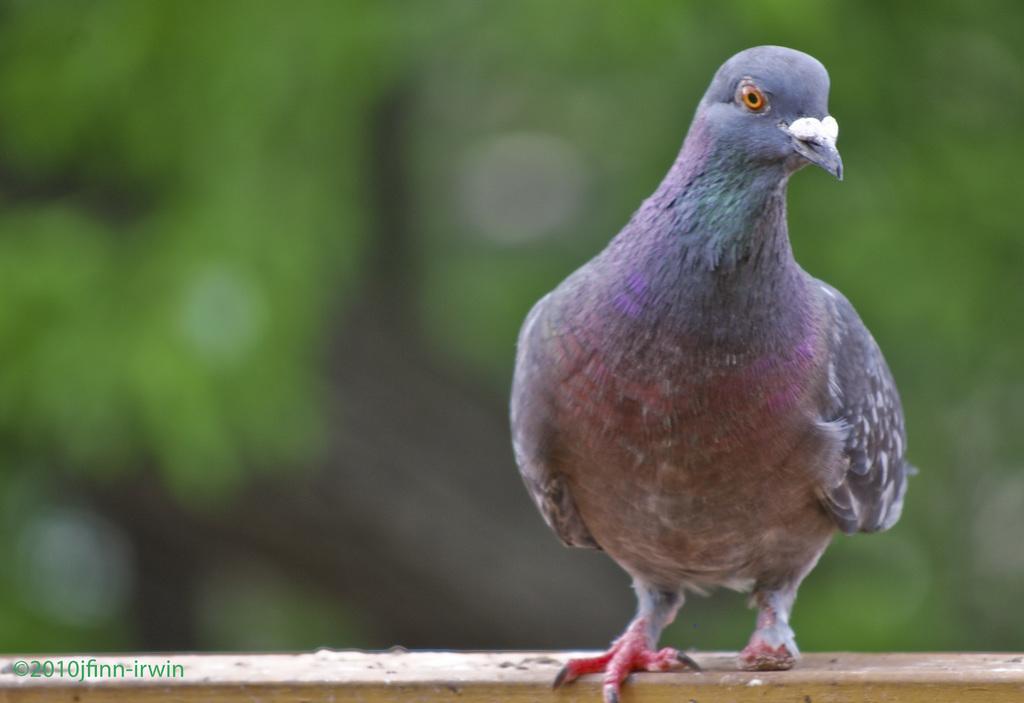Please provide a concise description of this image. In this image we can see one pigeon on a wooden stick, some text on this image, back side of the pigeon there is some brown and green color background. 